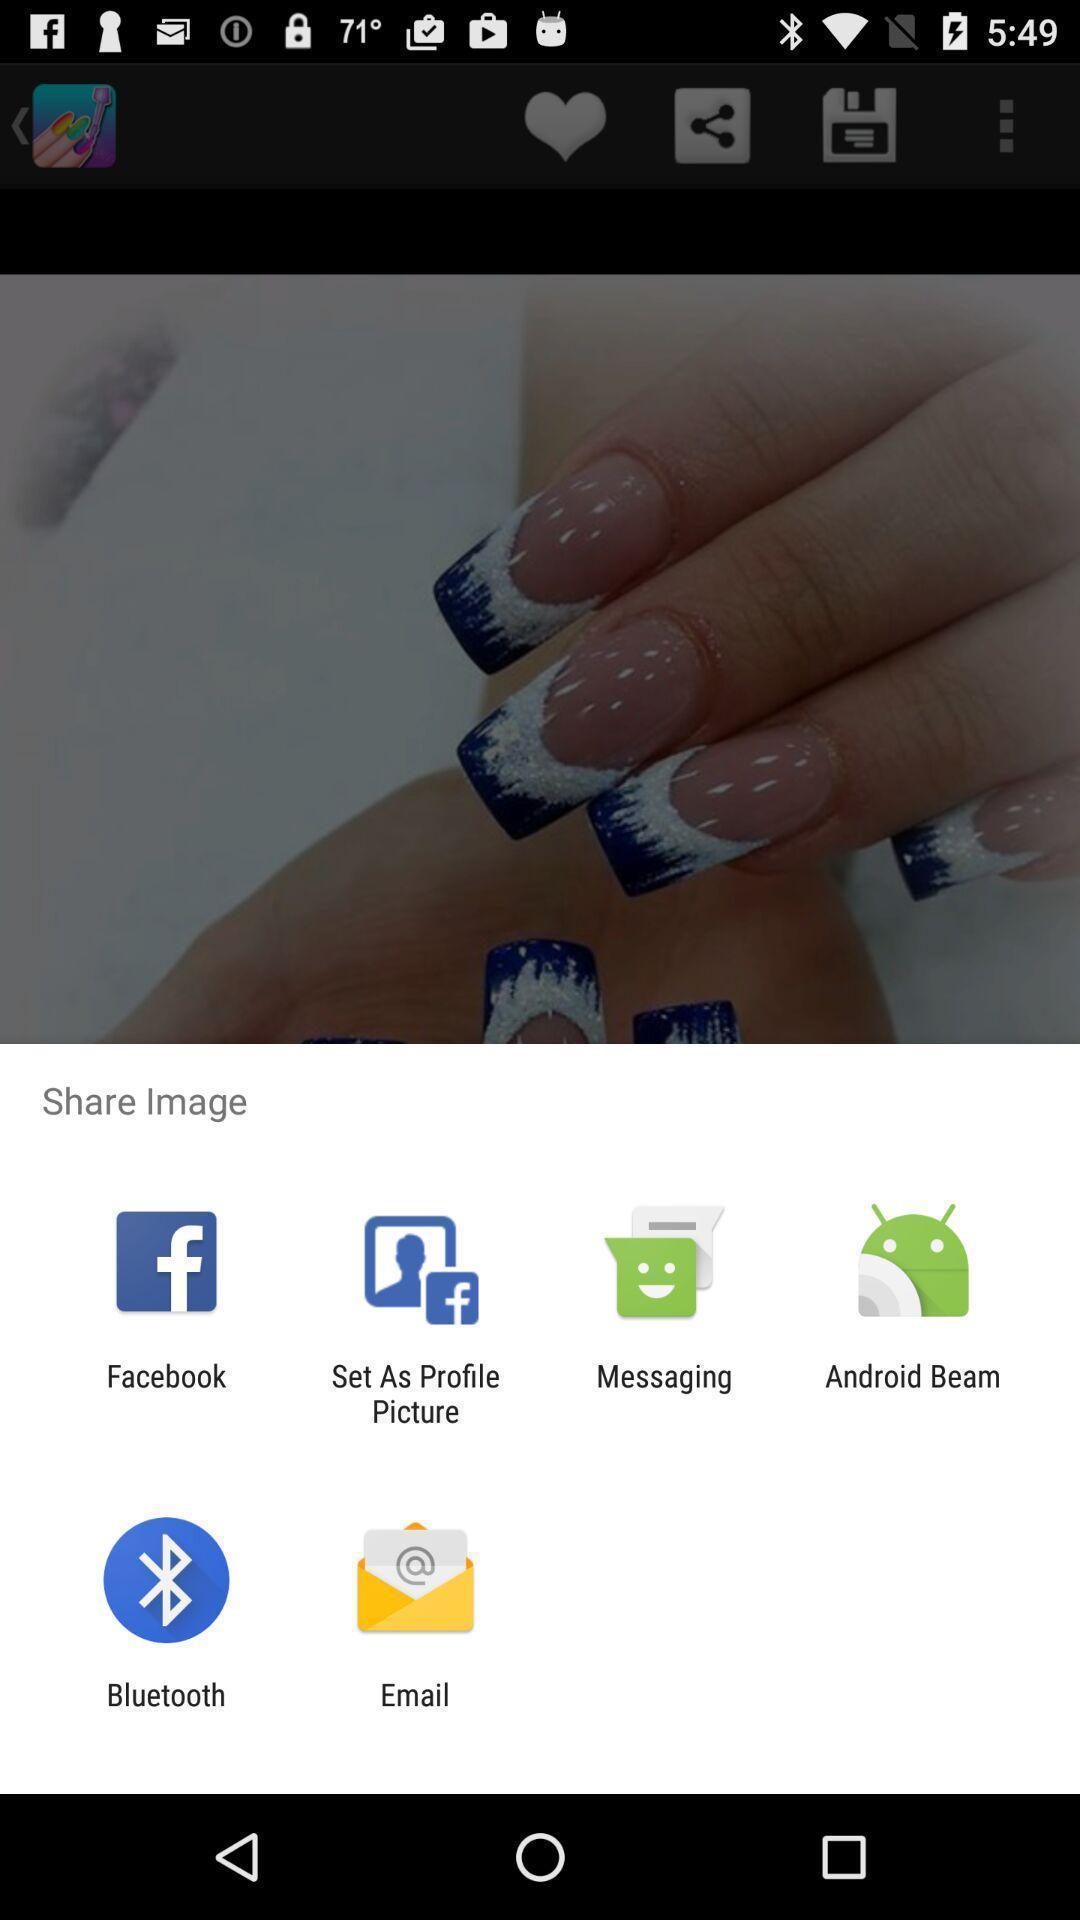Tell me what you see in this picture. Push up page showing app preference to share. 